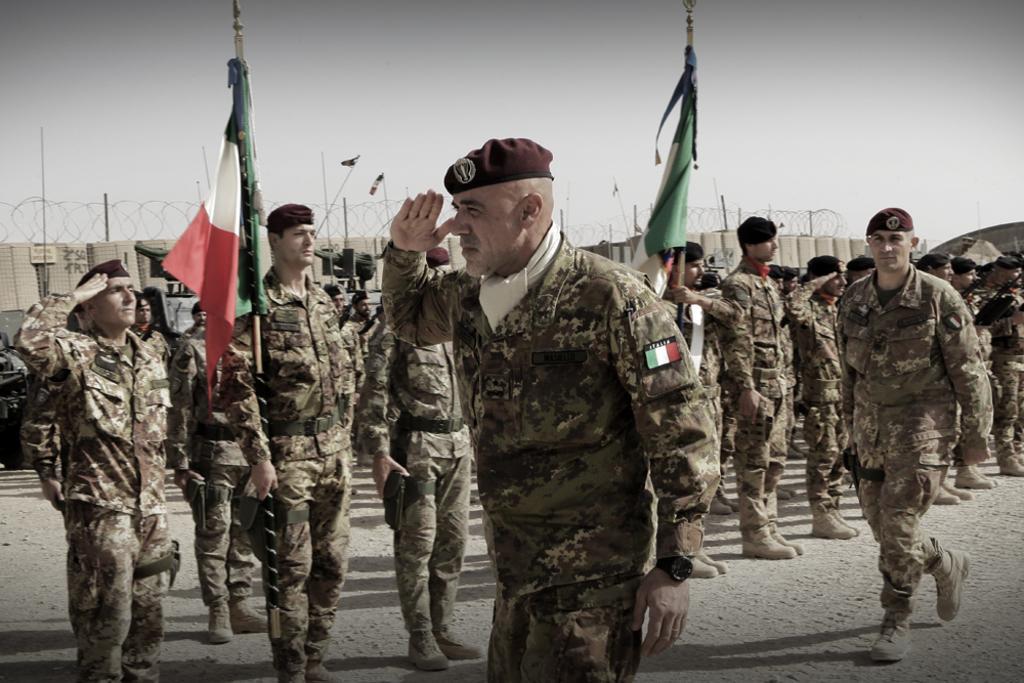In one or two sentences, can you explain what this image depicts? This is an outside view. Here I can see many people are wearing uniform and standing. Two men are walking on the ground, two men are holding flags in their hands. In the background there is net fencing. At the top of the image I can see the sky. 